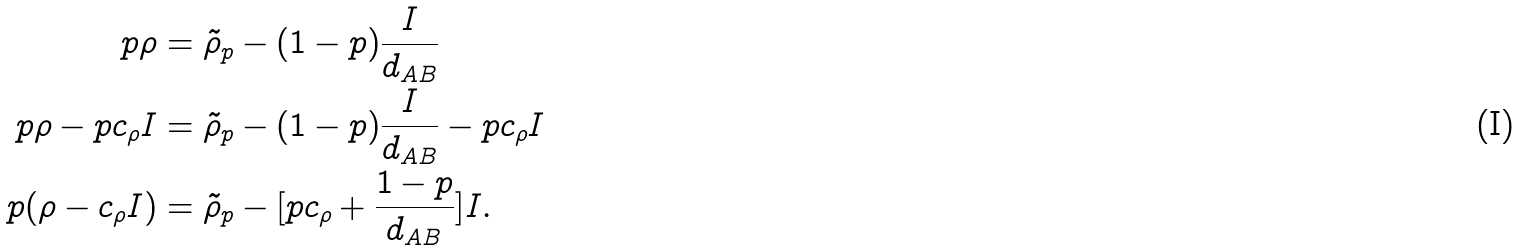<formula> <loc_0><loc_0><loc_500><loc_500>p \rho & = \tilde { \rho } _ { p } - ( 1 - p ) \frac { I } { d _ { A B } } \\ p \rho - p c _ { \rho } I & = \tilde { \rho } _ { p } - ( 1 - p ) \frac { I } { d _ { A B } } - p c _ { \rho } I \\ p ( \rho - c _ { \rho } I ) & = \tilde { \rho } _ { p } - [ p c _ { \rho } + \frac { 1 - p } { d _ { A B } } ] I .</formula> 